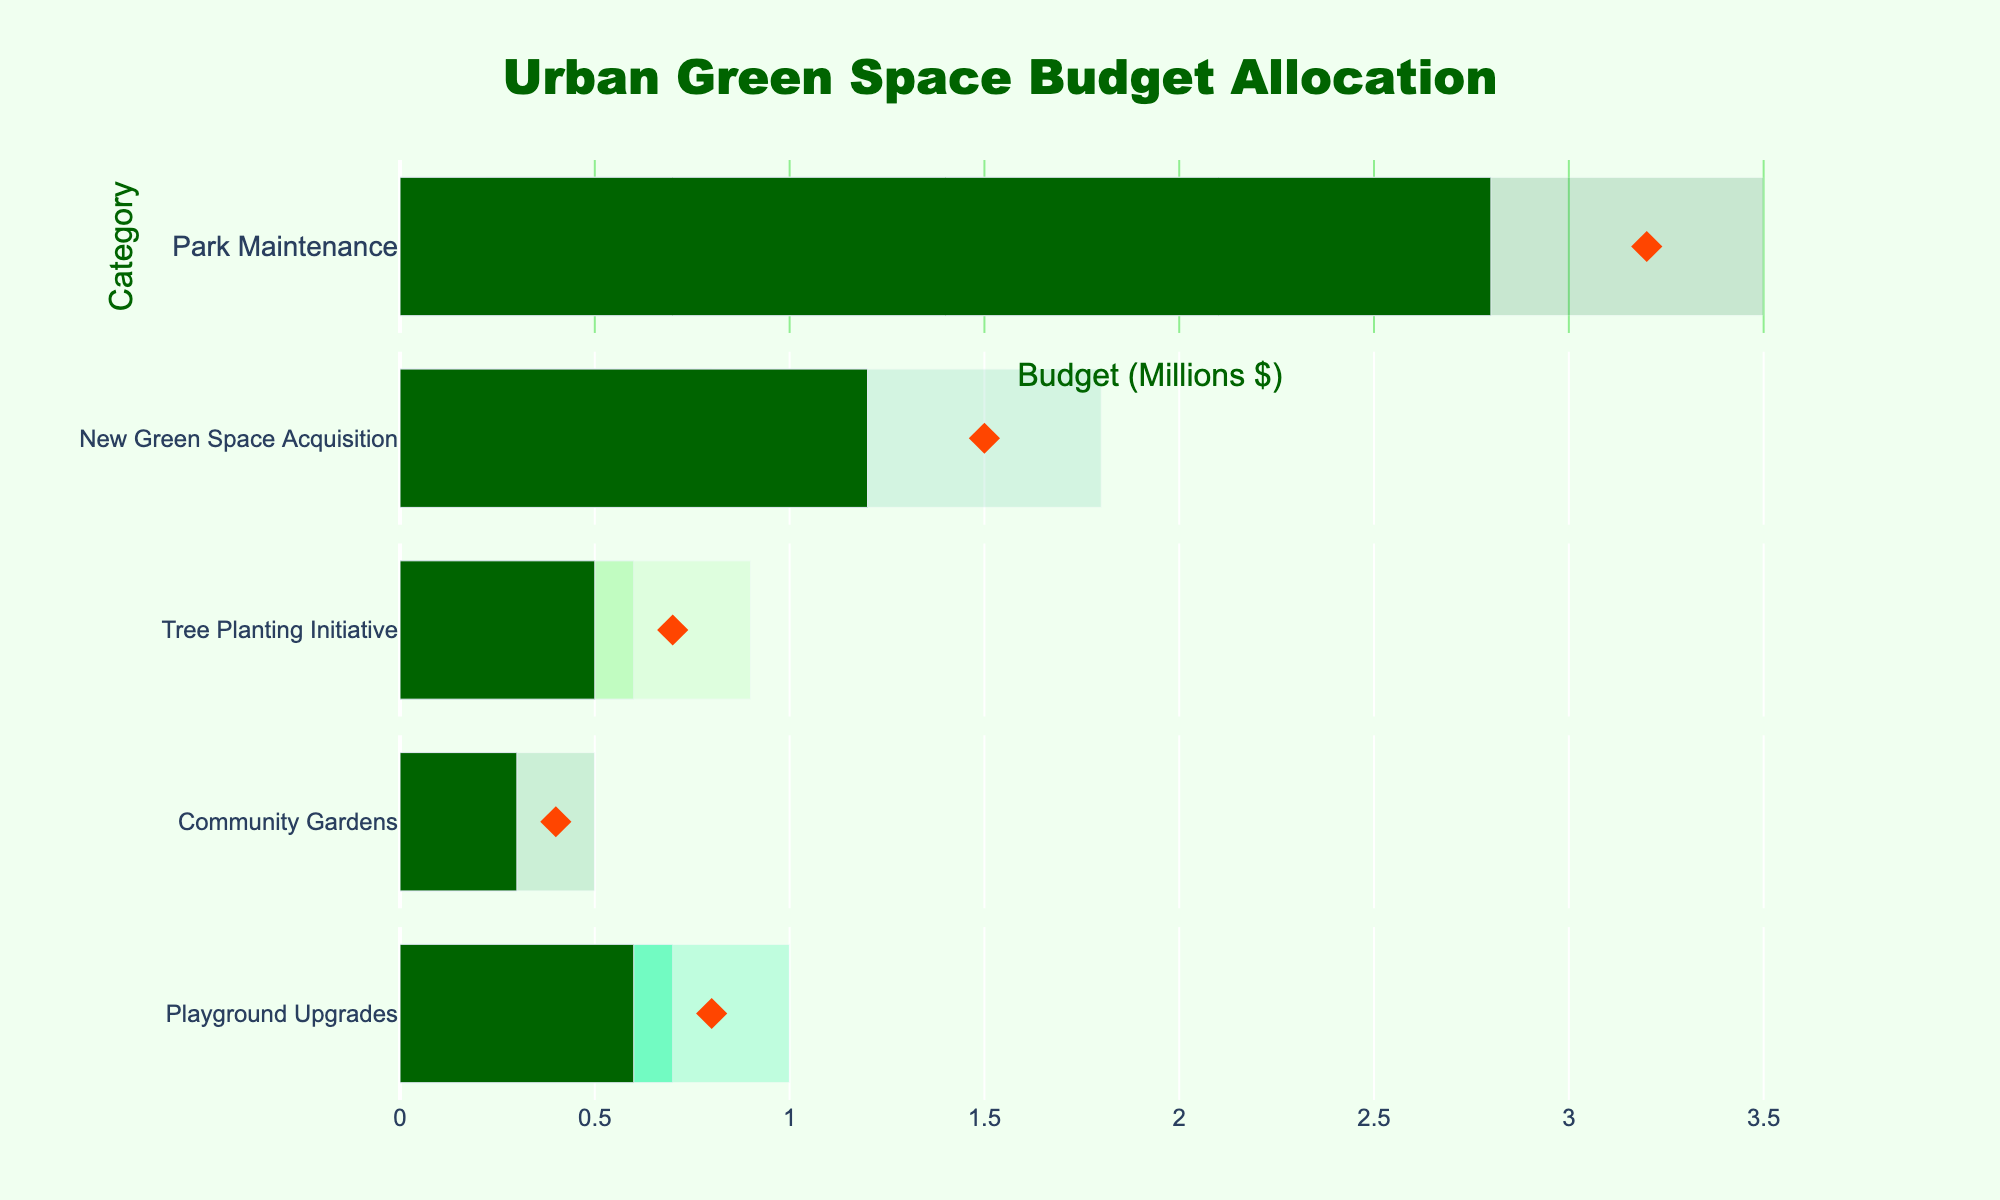What is the title of the figure? The title of the figure is presented at the top. It reads "Urban Green Space Budget Allocation".
Answer: Urban Green Space Budget Allocation How much actual budget was allocated for Playground Upgrades? Look for the 'Playground Upgrades' row and note the value in the 'Actual' column.
Answer: $0.6M What is the target budget for Tree Planting Initiative? Locate the 'Tree Planting Initiative' row and check the value in the 'Target' column.
Answer: $0.7M Which category has the highest actual budget allocation? Review all categories' actual budget allocations and identify the highest.
Answer: Park Maintenance How much more is the actual budget for Park Maintenance compared to New Green Space Acquisition? Subtract the actual budget of New Green Space Acquisition from the Park Maintenance actual budget: $2.8M - $1.2M.
Answer: $1.6M Does any category exceed its target budget? Compare the actual budget with the target budget for all categories to see if any actual value surpasses the corresponding target.
Answer: No How many categories have a target budget of $1.5M or less? Check each category's target budget and count those with a target of $1.5M or less.
Answer: 4 categories What is the smallest range (Range1) of budget among all categories? Examine the Range1 values for all categories and identify the smallest: $0.2M for Community Gardens.
Answer: $0.2M In which category is the actual budget closest to the target budget? Calculate the absolute difference between the actual and target budget for each category and identify the smallest difference: $0.2M for Tree Planting Initiative and Playground Upgrades.
Answer: Tree Planting Initiative and Playground Upgrades How does the actual budget for Community Gardens compare to its Range2? Compare the actual budget for Community Gardens ($0.3M) to its Range2 limit ($0.3M).
Answer: Equal to Range2 limit 